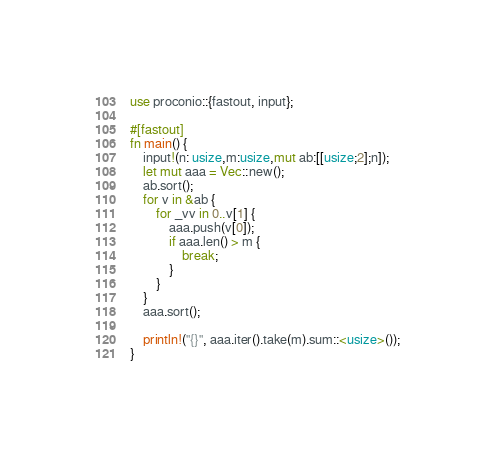Convert code to text. <code><loc_0><loc_0><loc_500><loc_500><_Rust_>use proconio::{fastout, input};

#[fastout]
fn main() {
    input!(n: usize,m:usize,mut ab:[[usize;2];n]);
    let mut aaa = Vec::new();
    ab.sort();
    for v in &ab {
        for _vv in 0..v[1] {
            aaa.push(v[0]);
            if aaa.len() > m {
                break;
            }
        }
    }
    aaa.sort();

    println!("{}", aaa.iter().take(m).sum::<usize>());
}
</code> 